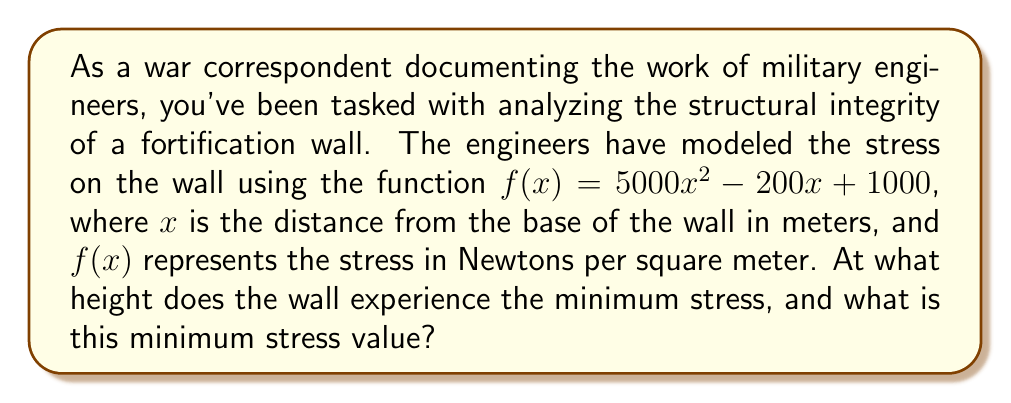Can you solve this math problem? To solve this problem, we need to follow these steps:

1) The function $f(x) = 5000x^2 - 200x + 1000$ is a quadratic function. The minimum or maximum of a quadratic function occurs at the vertex of the parabola.

2) For a quadratic function in the form $f(x) = ax^2 + bx + c$, the x-coordinate of the vertex is given by the formula:

   $x = -\frac{b}{2a}$

3) In our case, $a = 5000$, $b = -200$, and $c = 1000$. Let's substitute these values:

   $x = -\frac{(-200)}{2(5000)} = \frac{200}{10000} = 0.02$

4) This means the minimum stress occurs at a height of 0.02 meters or 2 centimeters from the base of the wall.

5) To find the minimum stress value, we need to evaluate $f(0.02)$:

   $$\begin{align}
   f(0.02) &= 5000(0.02)^2 - 200(0.02) + 1000 \\
   &= 5000(0.0004) - 4 + 1000 \\
   &= 2 - 4 + 1000 \\
   &= 998
   \end{align}$$

Therefore, the minimum stress is 998 Newtons per square meter.
Answer: The wall experiences minimum stress at a height of 0.02 meters (2 cm) from the base, and the minimum stress value is 998 N/m². 